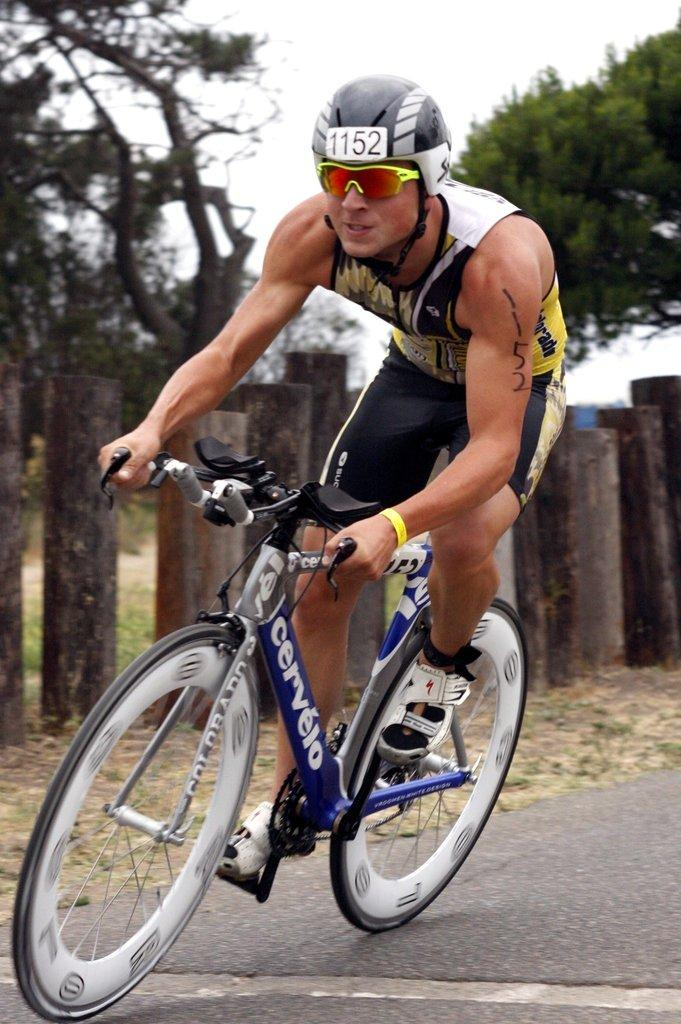What is the main subject of the image? There is a person riding a bicycle in the image. What can be seen in the background of the image? There are wooden objects and trees in the background of the image. What type of mind can be seen in the image? There is no mind present in the image; it features a person riding a bicycle and a background with wooden objects and trees. 